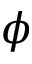<formula> <loc_0><loc_0><loc_500><loc_500>\phi</formula> 